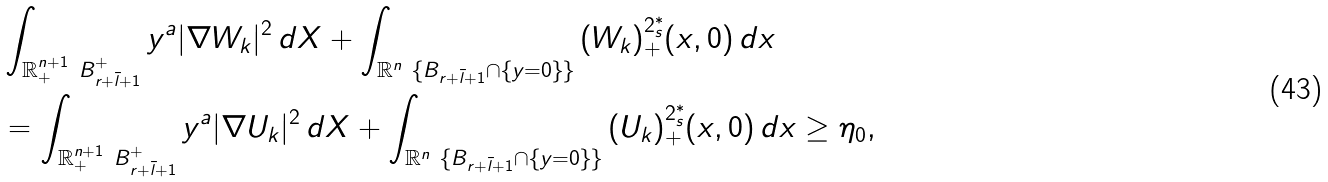Convert formula to latex. <formula><loc_0><loc_0><loc_500><loc_500>& \int _ { \mathbb { R } ^ { n + 1 } _ { + } \ B ^ { + } _ { r + \bar { l } + 1 } } { y ^ { a } | \nabla W _ { k } | ^ { 2 } \, d X } + \int _ { \mathbb { R } ^ { n } \ \{ B _ { r + \bar { l } + 1 } \cap \{ y = 0 \} \} } { ( W _ { k } ) _ { + } ^ { 2 ^ { * } _ { s } } ( x , 0 ) \, d x } \\ & = \int _ { \mathbb { R } ^ { n + 1 } _ { + } \ B ^ { + } _ { r + \bar { l } + 1 } } { y ^ { a } | \nabla U _ { k } | ^ { 2 } \, d X } + \int _ { \mathbb { R } ^ { n } \ \{ B _ { r + \bar { l } + 1 } \cap \{ y = 0 \} \} } { ( U _ { k } ) _ { + } ^ { 2 ^ { * } _ { s } } ( x , 0 ) \, d x } \geq \eta _ { 0 } ,</formula> 